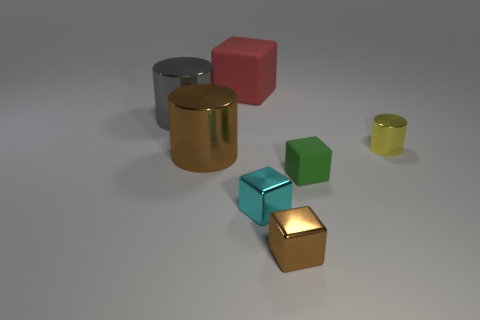Subtract 1 blocks. How many blocks are left? 3 Subtract all yellow blocks. Subtract all brown balls. How many blocks are left? 4 Add 2 big green metallic objects. How many objects exist? 9 Subtract all cubes. How many objects are left? 3 Add 1 green cubes. How many green cubes are left? 2 Add 2 yellow matte cubes. How many yellow matte cubes exist? 2 Subtract 0 purple spheres. How many objects are left? 7 Subtract all big metallic blocks. Subtract all yellow shiny objects. How many objects are left? 6 